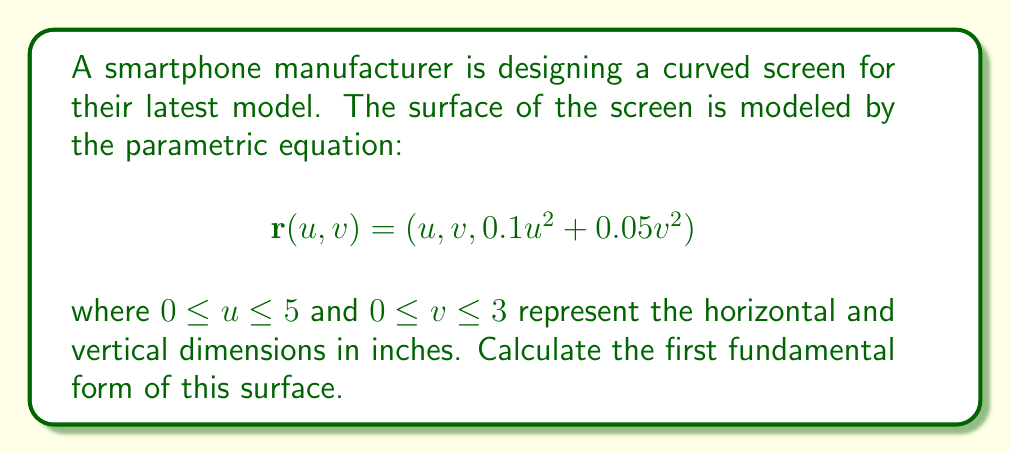Can you solve this math problem? To calculate the first fundamental form, we need to follow these steps:

1) The first fundamental form is given by:
   $$I = E du^2 + 2F du dv + G dv^2$$
   where $E = \mathbf{r}_u \cdot \mathbf{r}_u$, $F = \mathbf{r}_u \cdot \mathbf{r}_v$, and $G = \mathbf{r}_v \cdot \mathbf{r}_v$.

2) First, let's calculate $\mathbf{r}_u$ and $\mathbf{r}_v$:
   $$\mathbf{r}_u = (1, 0, 0.2u)$$
   $$\mathbf{r}_v = (0, 1, 0.1v)$$

3) Now, let's calculate E:
   $$E = \mathbf{r}_u \cdot \mathbf{r}_u = 1^2 + 0^2 + (0.2u)^2 = 1 + 0.04u^2$$

4) Next, let's calculate F:
   $$F = \mathbf{r}_u \cdot \mathbf{r}_v = 1 \cdot 0 + 0 \cdot 1 + 0.2u \cdot 0.1v = 0.02uv$$

5) Finally, let's calculate G:
   $$G = \mathbf{r}_v \cdot \mathbf{r}_v = 0^2 + 1^2 + (0.1v)^2 = 1 + 0.01v^2$$

6) Substituting these values into the first fundamental form equation:
   $$I = (1 + 0.04u^2) du^2 + 2(0.02uv) du dv + (1 + 0.01v^2) dv^2$$
Answer: $I = (1 + 0.04u^2) du^2 + 0.04uv du dv + (1 + 0.01v^2) dv^2$ 